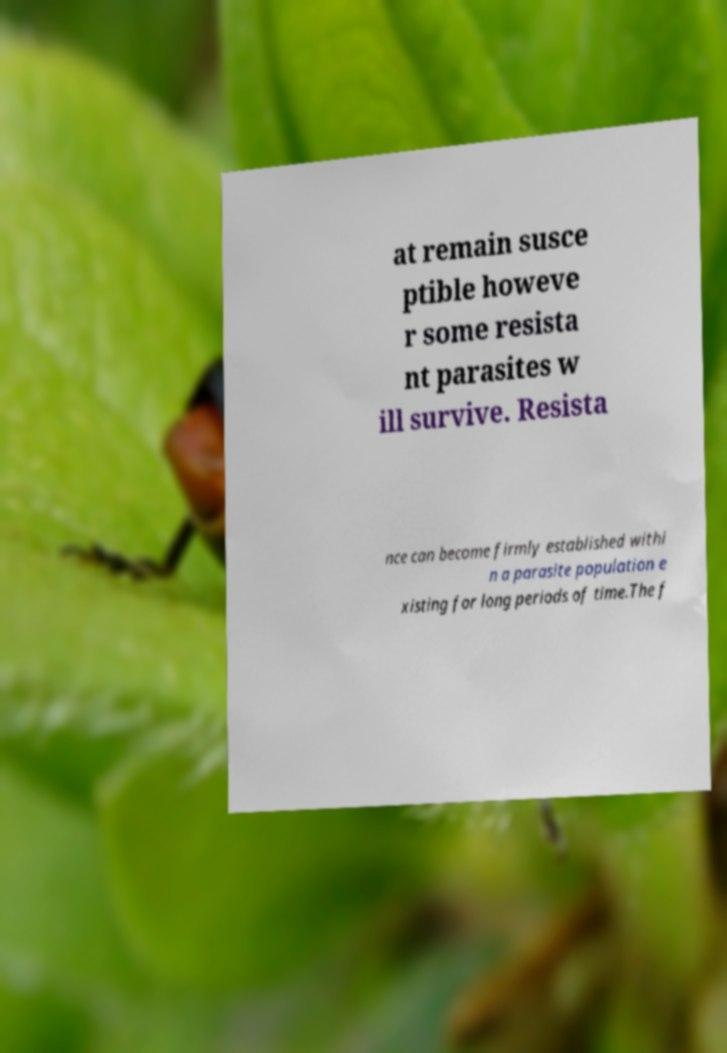Please read and relay the text visible in this image. What does it say? at remain susce ptible howeve r some resista nt parasites w ill survive. Resista nce can become firmly established withi n a parasite population e xisting for long periods of time.The f 